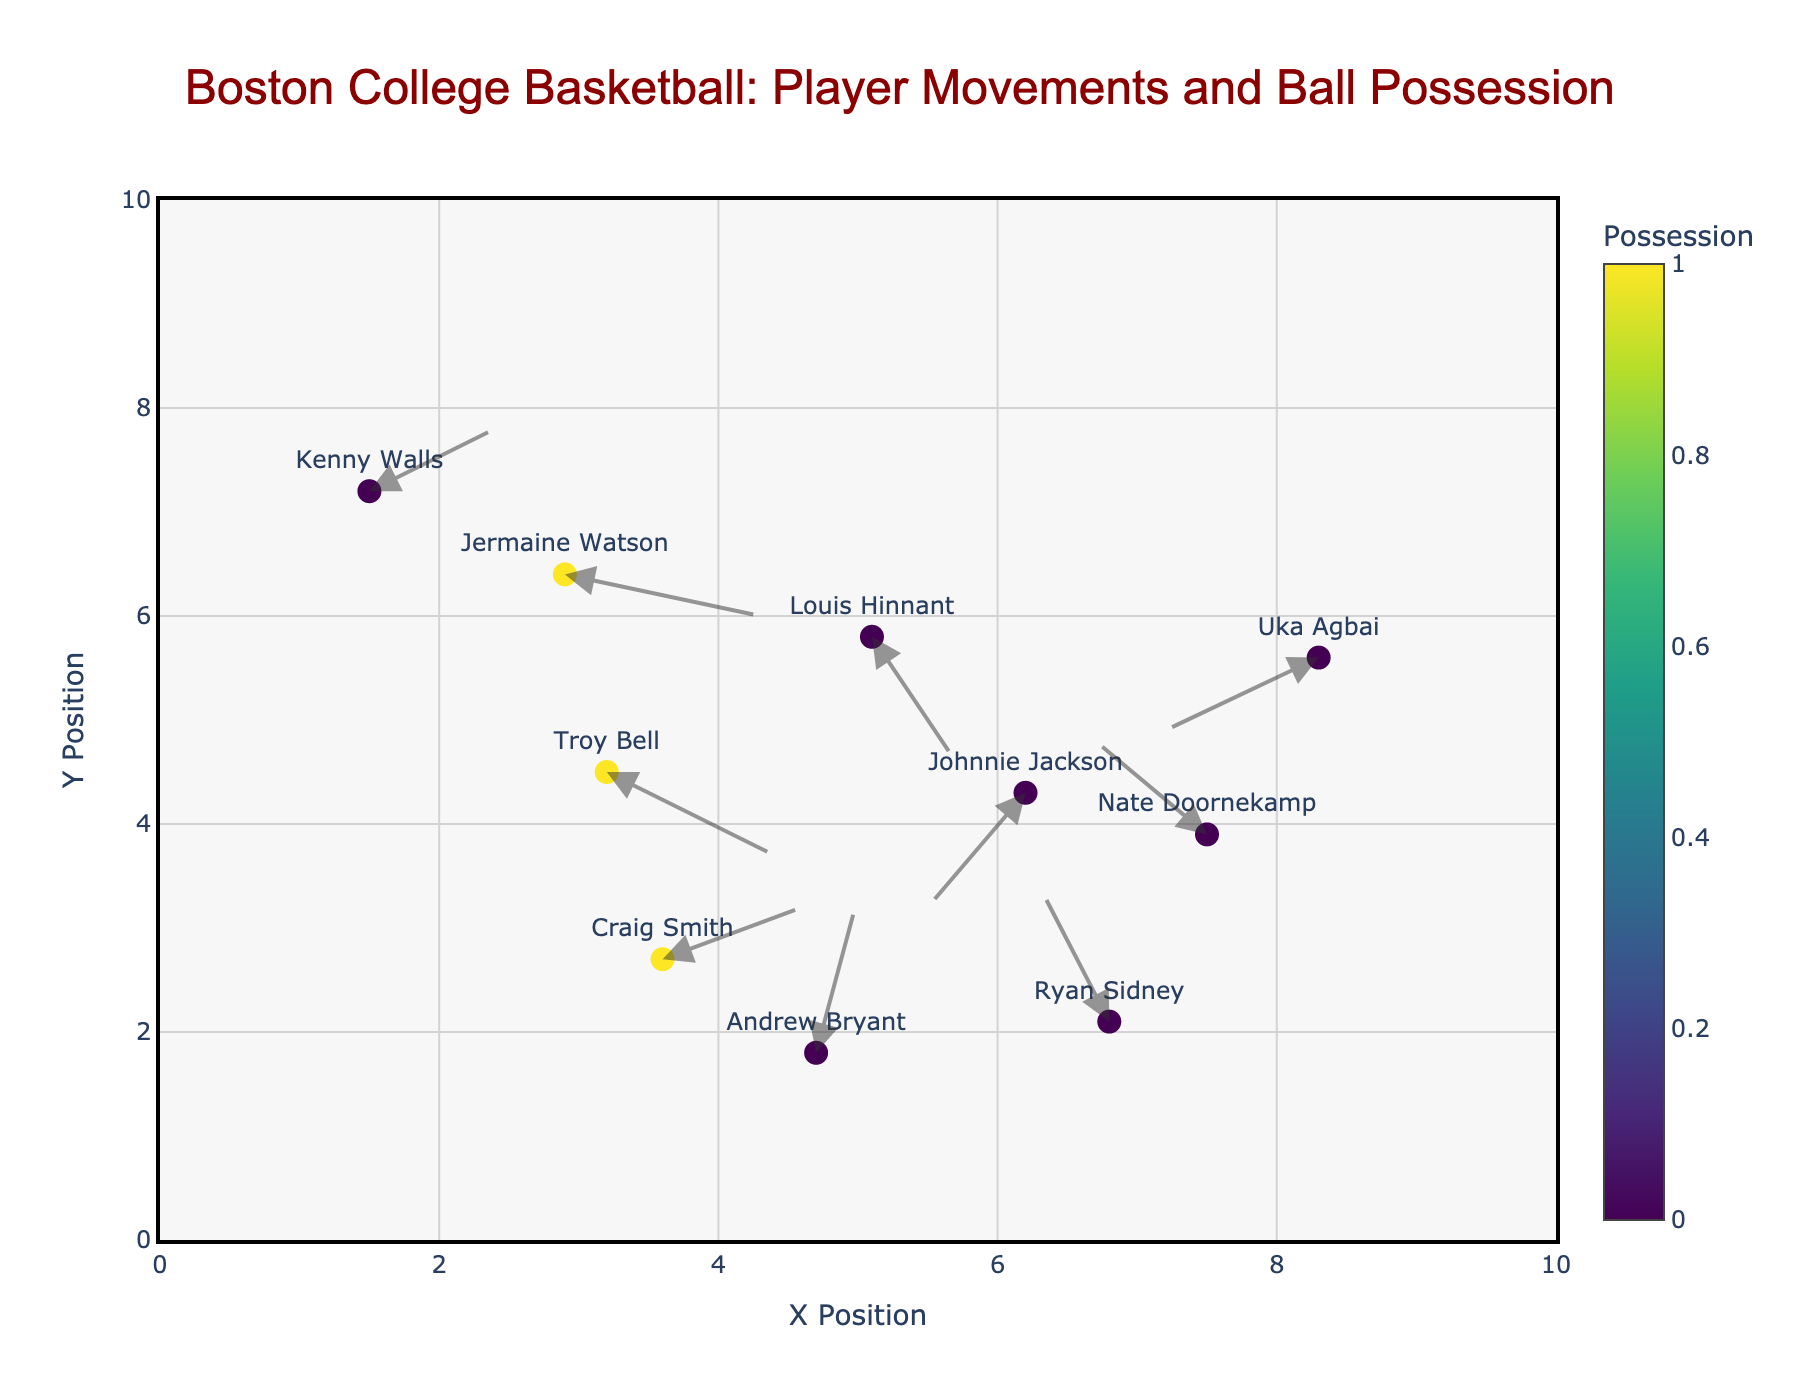What colors are used to represent the possession status of players in the plot? The plot uses a color gradient from the Viridis color scale. Players with ball possession are marked with a distinct color, while those without possession have another unique color.
Answer: Gradient from the Viridis color scale What is the x-position range displayed on the plot? The x-axis range is specified in the plot's layout settings and spans from 0 to 10. This can be observed on the x-axis of the plot.
Answer: 0 to 10 Which player has the longest movement trajectory? By visually inspecting the lengths of the arrows, the player with the longest movement trajectory can be identified. Craig Smith has the longest arrow indicating a movement of (1.0, 0.5).
Answer: Craig Smith How many players have ball possession? Players with ball possession are indicated in the plot by a specific color. By counting the distinct markers with this color, we find that there are three players with possession (Troy Bell, Jermaine Watson, Craig Smith).
Answer: 3 What is the average initial y-position of players without ball possession? To find the average initial y-position, sum the y-positions of players without possession (2.1 + 7.2 + 5.6 + 1.8 + 5.8 + 3.9 + 4.3) and divide by the number of such players (7).
Answer: (2.1+7.2+5.6+1.8+5.8+3.9+4.3)/7 = 30.7/7 = 4.39 Which player has the smallest movement in the x-direction? By comparing the change in x-position (dx) across all players, the smallest value can be identified. Andrew Bryant has the smallest dx (0.3).
Answer: Andrew Bryant Who moves to the right and also has ball possession? By checking movements where dx > 0 and possession = 1, we identify the player who meets both criteria. Both Troy Bell and Craig Smith move to the right and have possession.
Answer: Troy Bell, Craig Smith What is the direction of movement of Ryan Sidney? The direction of movement can be derived from the dx and dy values. With values of -0.5 and 1.3, the movement is leftward and upward.
Answer: Leftward and upward How does the movement pattern of Johnnie Jackson compare to that of Uka Agbai? By comparing the dx and dy values of both players, we see that Johnnie Jackson moves leftward and downward (-0.7, -1.1), while Uka Agbai moves leftward and slightly downward (-1.1, -0.7). Johnnie Jackson moves further in the y-direction.
Answer: Johnnie Jackson moves more downward What is the total upward movement in y-direction of players? To find the total upward movement, sum the upward dy values (positive dy) across all players (Ryan Sidney 1.3, Kenny Walls 0.6, Andrew Bryant 1.5, Nate Doornekamp 0.9).
Answer: 1.3 + 0.6 + 1.5 + 0.9 = 4.3 